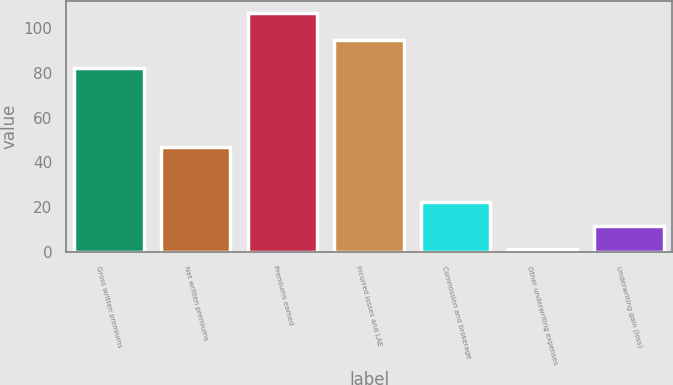<chart> <loc_0><loc_0><loc_500><loc_500><bar_chart><fcel>Gross written premiums<fcel>Net written premiums<fcel>Premiums earned<fcel>Incurred losses and LAE<fcel>Commission and brokerage<fcel>Other underwriting expenses<fcel>Underwriting gain (loss)<nl><fcel>82.2<fcel>46.9<fcel>106.7<fcel>94.7<fcel>22.22<fcel>1.1<fcel>11.66<nl></chart> 